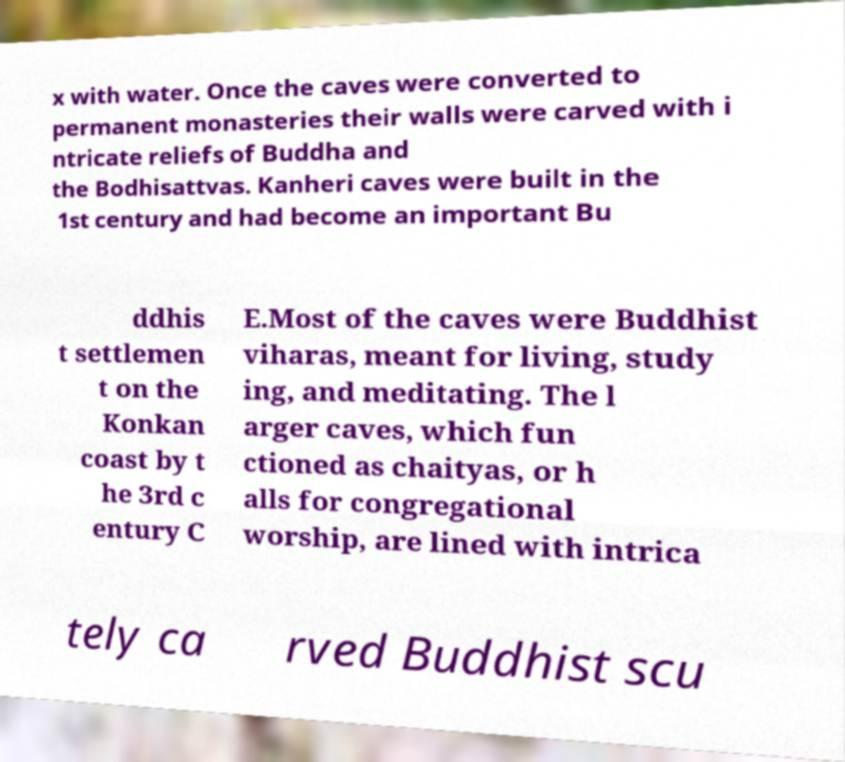Can you accurately transcribe the text from the provided image for me? x with water. Once the caves were converted to permanent monasteries their walls were carved with i ntricate reliefs of Buddha and the Bodhisattvas. Kanheri caves were built in the 1st century and had become an important Bu ddhis t settlemen t on the Konkan coast by t he 3rd c entury C E.Most of the caves were Buddhist viharas, meant for living, study ing, and meditating. The l arger caves, which fun ctioned as chaityas, or h alls for congregational worship, are lined with intrica tely ca rved Buddhist scu 